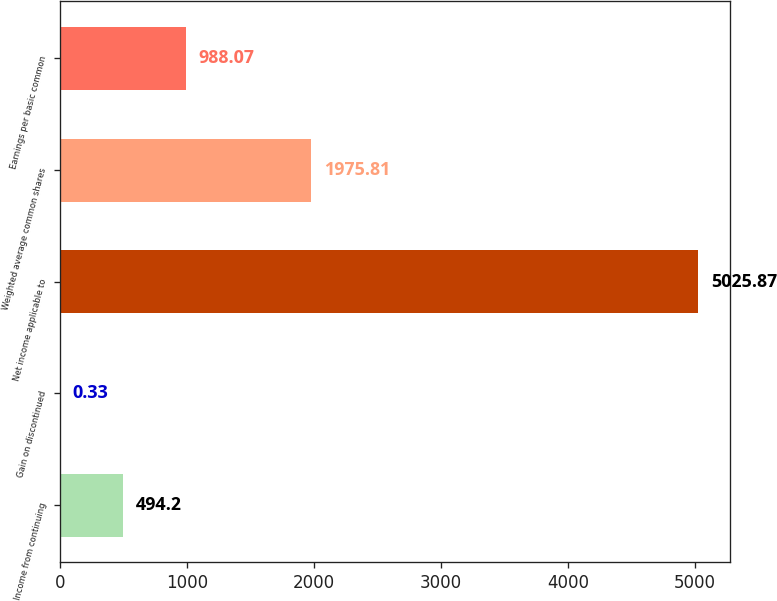Convert chart. <chart><loc_0><loc_0><loc_500><loc_500><bar_chart><fcel>Income from continuing<fcel>Gain on discontinued<fcel>Net income applicable to<fcel>Weighted average common shares<fcel>Earnings per basic common<nl><fcel>494.2<fcel>0.33<fcel>5025.87<fcel>1975.81<fcel>988.07<nl></chart> 